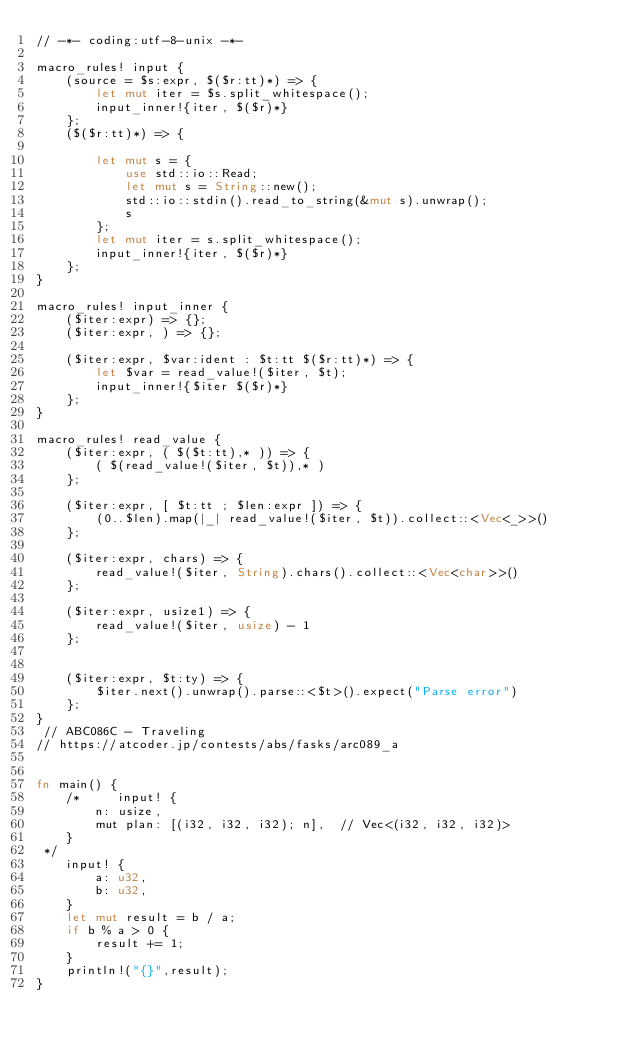Convert code to text. <code><loc_0><loc_0><loc_500><loc_500><_Rust_>// -*- coding:utf-8-unix -*-

macro_rules! input {
    (source = $s:expr, $($r:tt)*) => {
        let mut iter = $s.split_whitespace();
        input_inner!{iter, $($r)*}
    };
    ($($r:tt)*) => {
 
        let mut s = {
            use std::io::Read;
            let mut s = String::new();
            std::io::stdin().read_to_string(&mut s).unwrap();
            s
        };
        let mut iter = s.split_whitespace();
        input_inner!{iter, $($r)*}
    };
}
 
macro_rules! input_inner {
    ($iter:expr) => {};
    ($iter:expr, ) => {};
 
    ($iter:expr, $var:ident : $t:tt $($r:tt)*) => {
        let $var = read_value!($iter, $t);
        input_inner!{$iter $($r)*}
    };
}
 
macro_rules! read_value {
    ($iter:expr, ( $($t:tt),* )) => {
        ( $(read_value!($iter, $t)),* )
    };
 
    ($iter:expr, [ $t:tt ; $len:expr ]) => {
        (0..$len).map(|_| read_value!($iter, $t)).collect::<Vec<_>>()
    };
 
    ($iter:expr, chars) => {
        read_value!($iter, String).chars().collect::<Vec<char>>()
    };
 
    ($iter:expr, usize1) => {
        read_value!($iter, usize) - 1
    };
 
 
    ($iter:expr, $t:ty) => {
        $iter.next().unwrap().parse::<$t>().expect("Parse error")
    };
}
 // ABC086C - Traveling
// https://atcoder.jp/contests/abs/fasks/arc089_a
 

fn main() {
    /*     input! {
        n: usize,
        mut plan: [(i32, i32, i32); n],  // Vec<(i32, i32, i32)>
    }
 */
    input! {
        a: u32,
        b: u32,
    }
    let mut result = b / a;
    if b % a > 0 {
        result += 1;
    }
    println!("{}",result);
}
</code> 